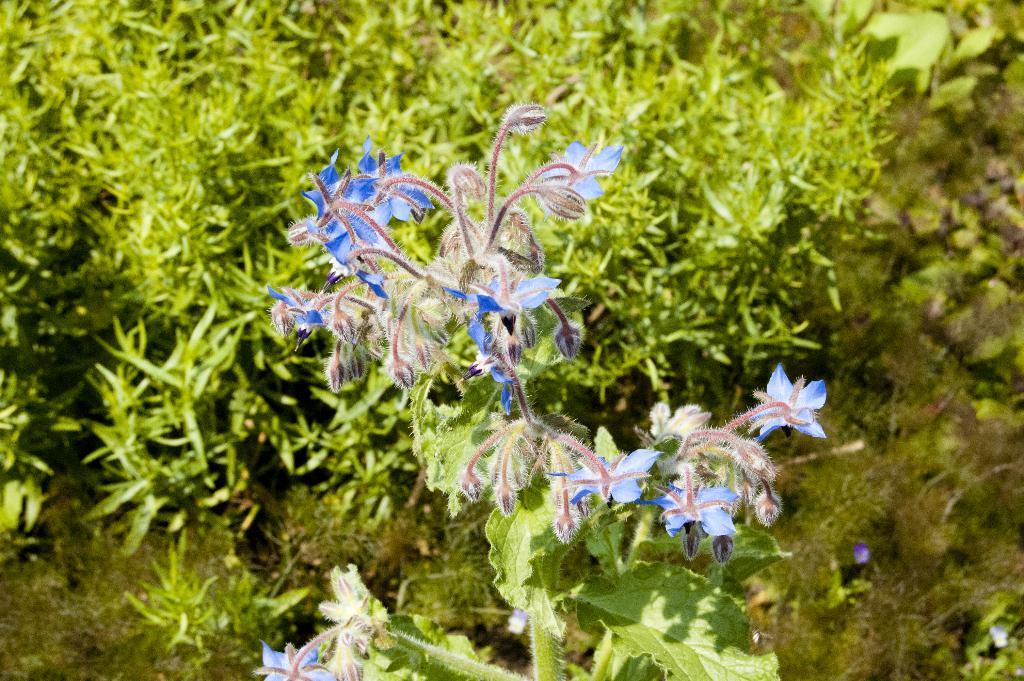What can be seen in the foreground of the picture? There are flowers and leaves of a plant in the foreground of the picture. What else is visible in the background of the picture? There are plants, grass, and soil in the background of the picture. What type of cover can be seen in the picture? There is no cover present in the picture; it features flowers, leaves, plants, grass, and soil. What type of fight can be seen taking place in the picture? There is no fight present in the picture; it features natural elements such as flowers, leaves, plants, grass, and soil. 